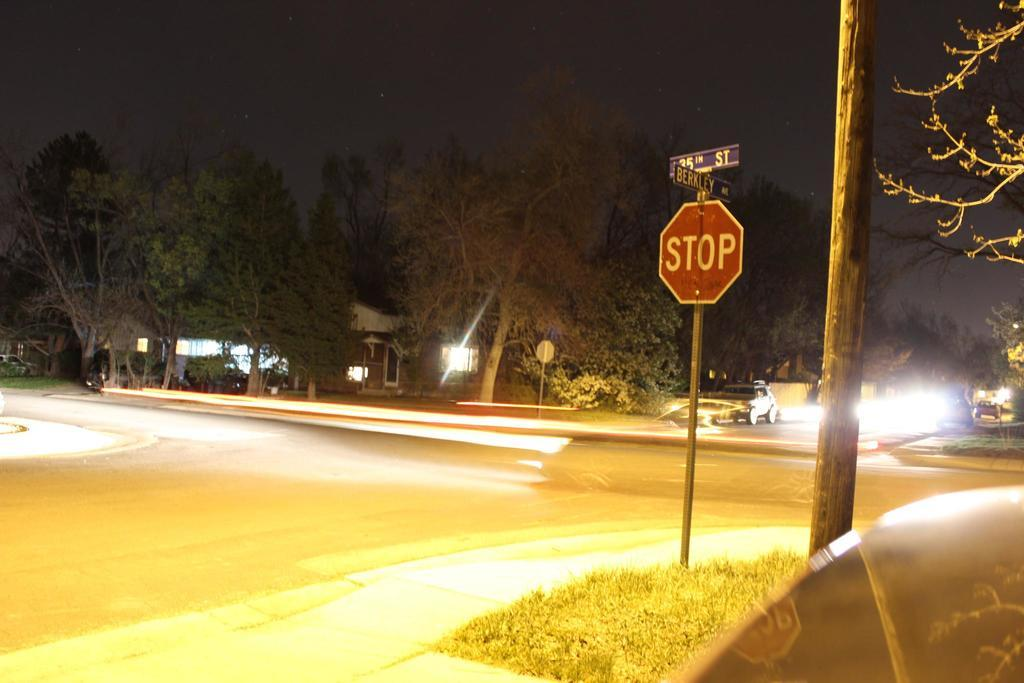Provide a one-sentence caption for the provided image. Bright lights shine on a Berkley Ave sign. 